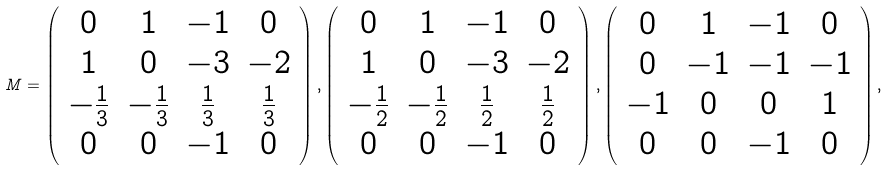<formula> <loc_0><loc_0><loc_500><loc_500>M = \left ( \begin{array} { c c c c } 0 & 1 & - 1 & 0 \\ 1 & 0 & - 3 & - 2 \\ - \frac { 1 } { 3 } & - \frac { 1 } { 3 } & \frac { 1 } { 3 } & \frac { 1 } { 3 } \\ 0 & 0 & - 1 & 0 \end{array} \right ) , \left ( \begin{array} { c c c c } 0 & 1 & - 1 & 0 \\ 1 & 0 & - 3 & - 2 \\ - \frac { 1 } { 2 } & - \frac { 1 } { 2 } & \frac { 1 } { 2 } & \frac { 1 } { 2 } \\ 0 & 0 & - 1 & 0 \end{array} \right ) , \left ( \begin{array} { c c c c } 0 & 1 & - 1 & 0 \\ 0 & - 1 & - 1 & - 1 \\ - 1 & 0 & 0 & 1 \\ 0 & 0 & - 1 & 0 \end{array} \right ) ,</formula> 